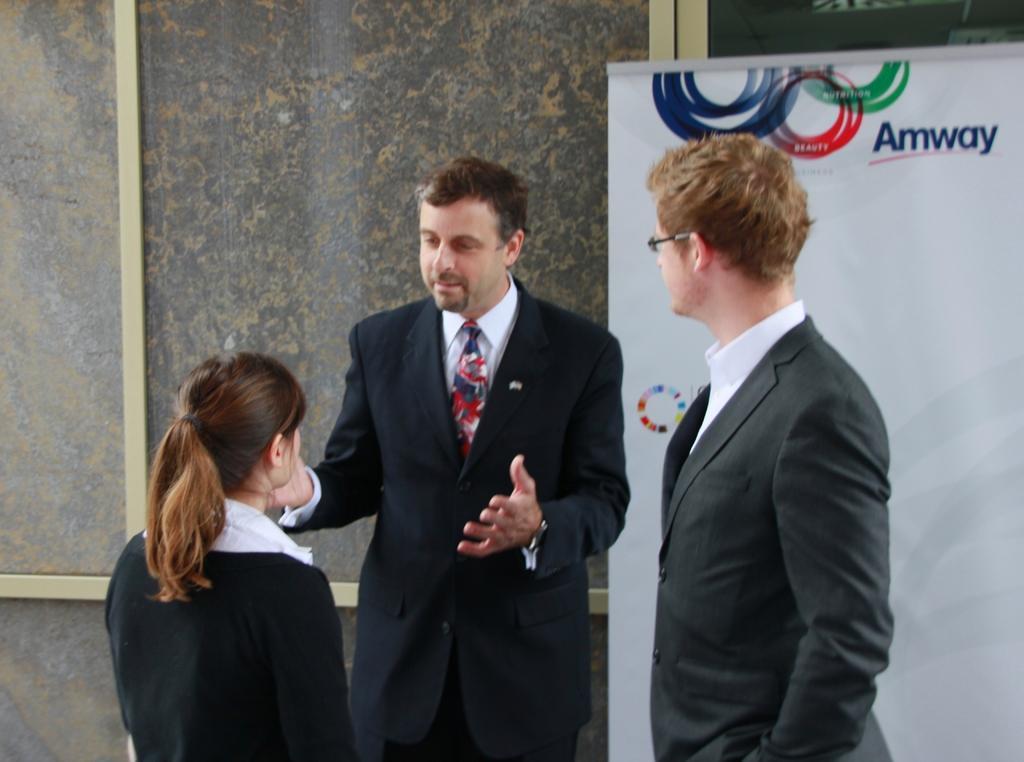Describe this image in one or two sentences. In the center of the image, we can see people standing and are wearing coats and one of them is wearing glasses. In the background, there is a banner and we can see a board. 